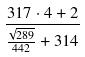<formula> <loc_0><loc_0><loc_500><loc_500>\frac { 3 1 7 \cdot 4 + 2 } { \frac { \sqrt { 2 8 9 } } { 4 4 2 } + 3 1 4 }</formula> 